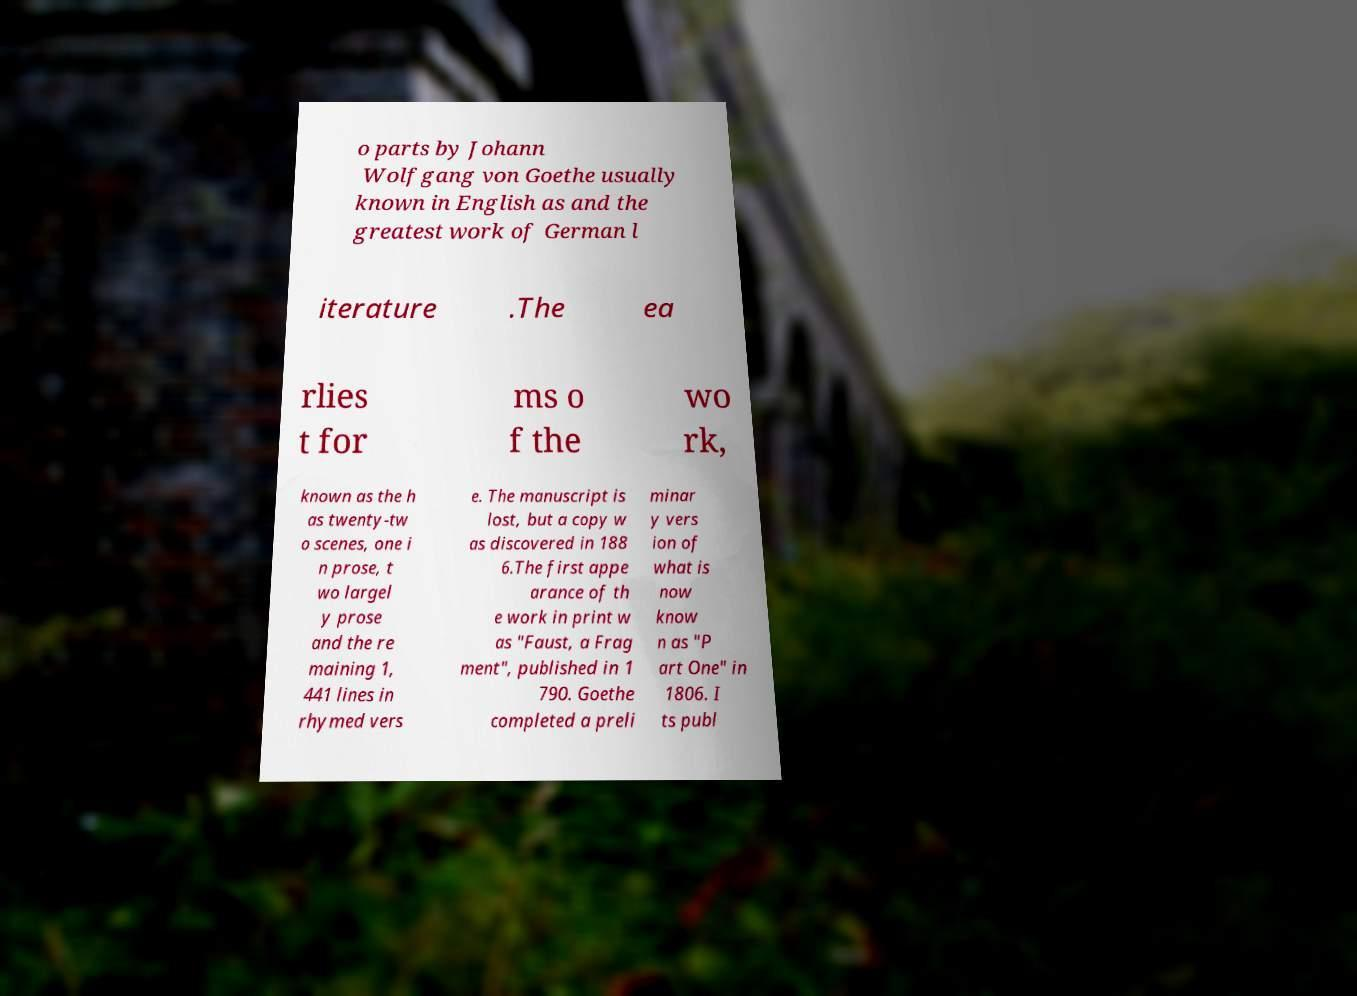I need the written content from this picture converted into text. Can you do that? o parts by Johann Wolfgang von Goethe usually known in English as and the greatest work of German l iterature .The ea rlies t for ms o f the wo rk, known as the h as twenty-tw o scenes, one i n prose, t wo largel y prose and the re maining 1, 441 lines in rhymed vers e. The manuscript is lost, but a copy w as discovered in 188 6.The first appe arance of th e work in print w as "Faust, a Frag ment", published in 1 790. Goethe completed a preli minar y vers ion of what is now know n as "P art One" in 1806. I ts publ 